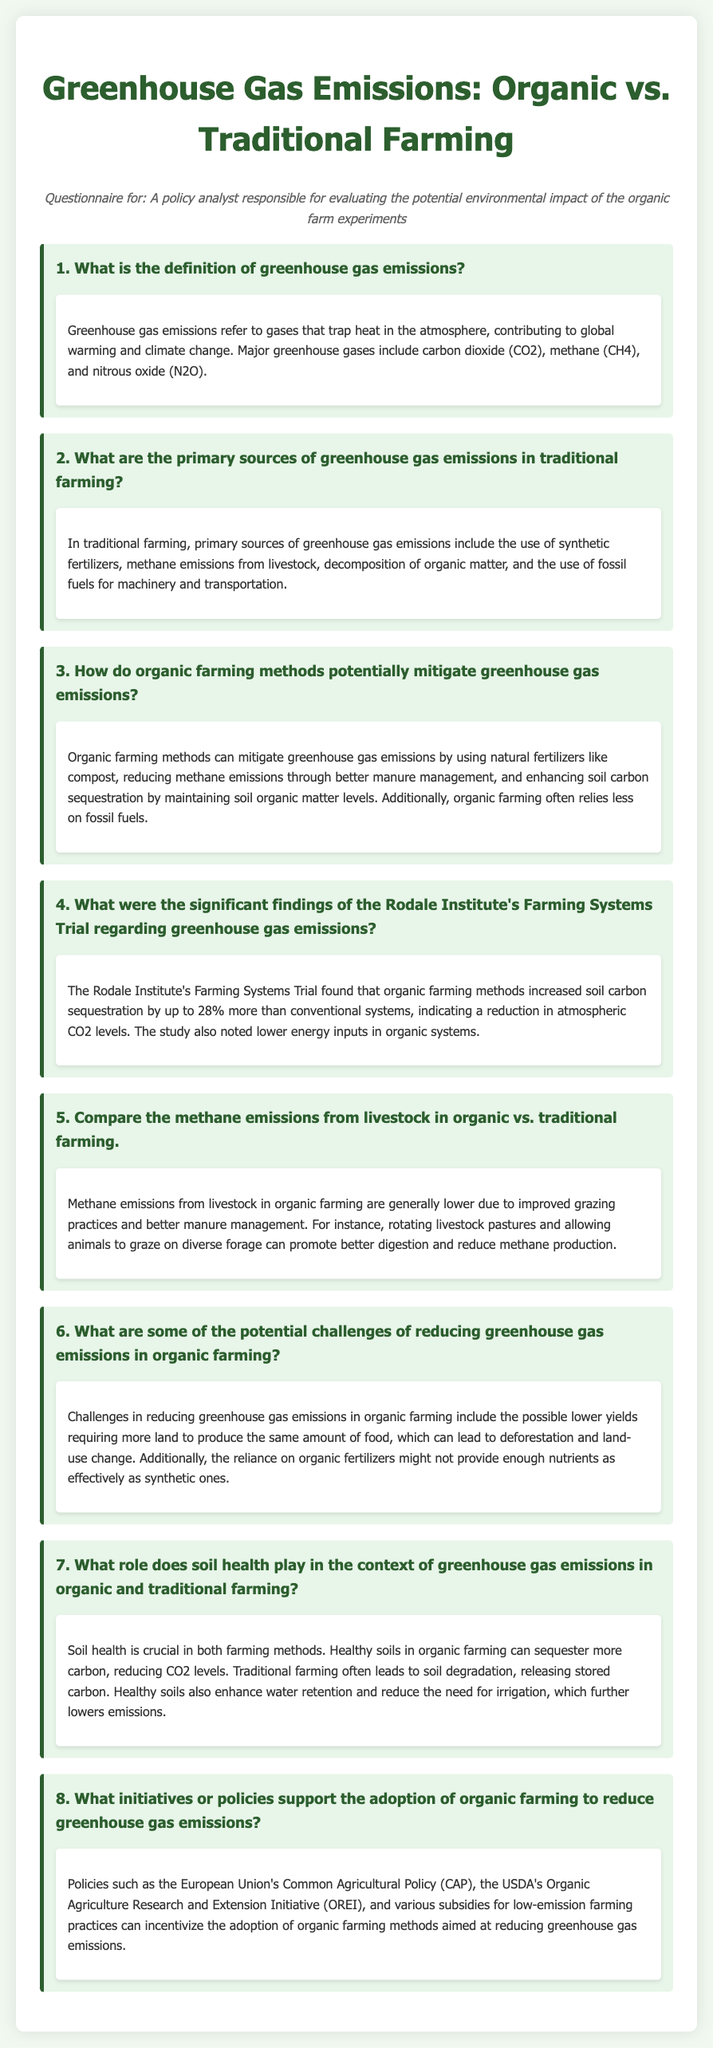What is the primary gas responsible for global warming? The document explains that greenhouse gases trap heat in the atmosphere, with notable examples including carbon dioxide, methane, and nitrous oxide.
Answer: carbon dioxide What do organic farming methods use to reduce greenhouse gas emissions? The document states that organic farming methods utilize natural fertilizers like compost to mitigate emissions.
Answer: natural fertilizers What percentage more soil carbon sequestration was observed in organic farming according to the Rodale Institute's study? It mentions that organic farming methods increased soil carbon sequestration by up to 28% more than conventional systems.
Answer: 28% What farming practice can help lower methane emissions from livestock in organic systems? The answer can be found in the section discussing methane emissions, stating that rotating livestock pastures can promote better digestion and reduce methane production.
Answer: rotating livestock pastures What is one challenge of organic farming concerning land use? The document specifies that lower yields in organic farming might require more land, potentially leading to deforestation.
Answer: deforestation What role does soil health play in reducing greenhouse gas emissions? According to the document, healthy soils can sequester more carbon, which helps in reducing CO2 levels.
Answer: sequester more carbon What major policy supports organic farming adoption? The document lists various policies, including the USDA's Organic Agriculture Research and Extension Initiative, that incentivize organic farming to reduce emissions.
Answer: USDA's Organic Agriculture Research and Extension Initiative What type of fertilizers do traditional farming predominantly use? The answer is in the part discussing sources of emissions from traditional farming, which mentions synthetic fertilizers.
Answer: synthetic fertilizers 